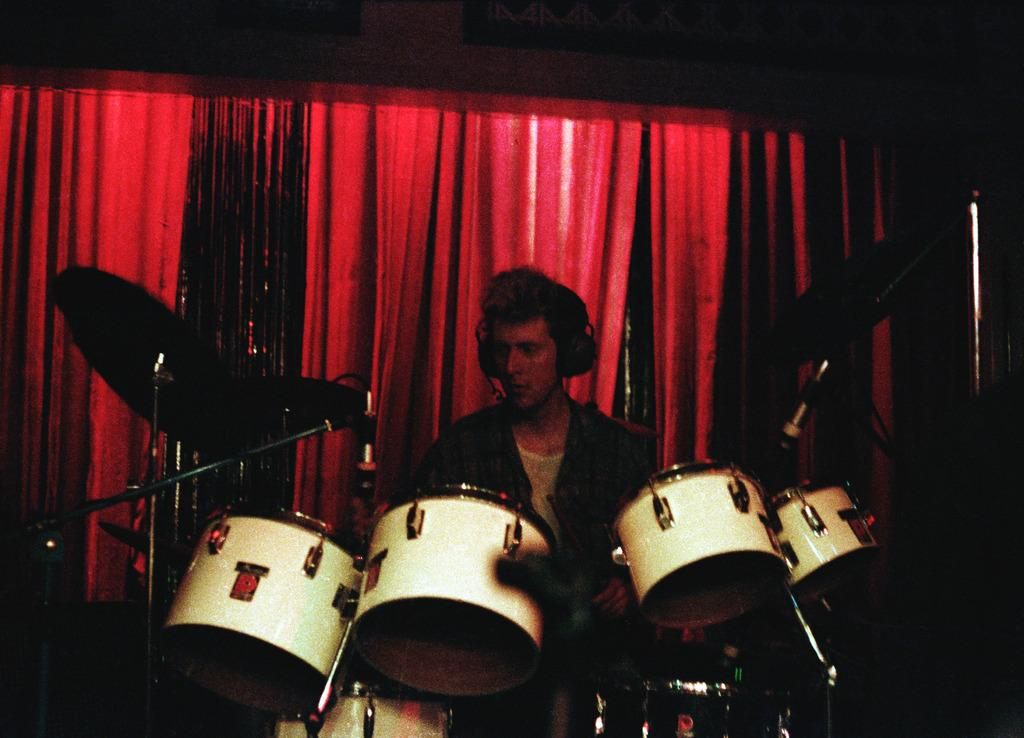What is the main subject of the image? There is a person in the image. What is the person doing in the image? The person is playing a musical instrument. Can you describe the background of the image? There is a red color cloth in the background of the image. What type of oil can be seen dripping from the musical instrument in the image? There is no oil present in the image, and the musical instrument is not depicted as dripping anything. 